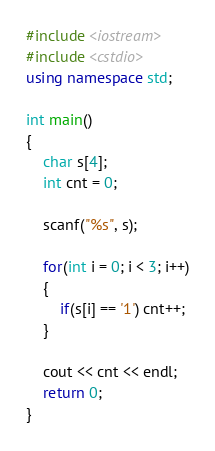<code> <loc_0><loc_0><loc_500><loc_500><_C++_>#include <iostream>
#include <cstdio>
using namespace std;

int main()
{
    char s[4];
    int cnt = 0;

    scanf("%s", s);
    
    for(int i = 0; i < 3; i++)
    {
        if(s[i] == '1') cnt++;
    }

    cout << cnt << endl;
    return 0;
}</code> 